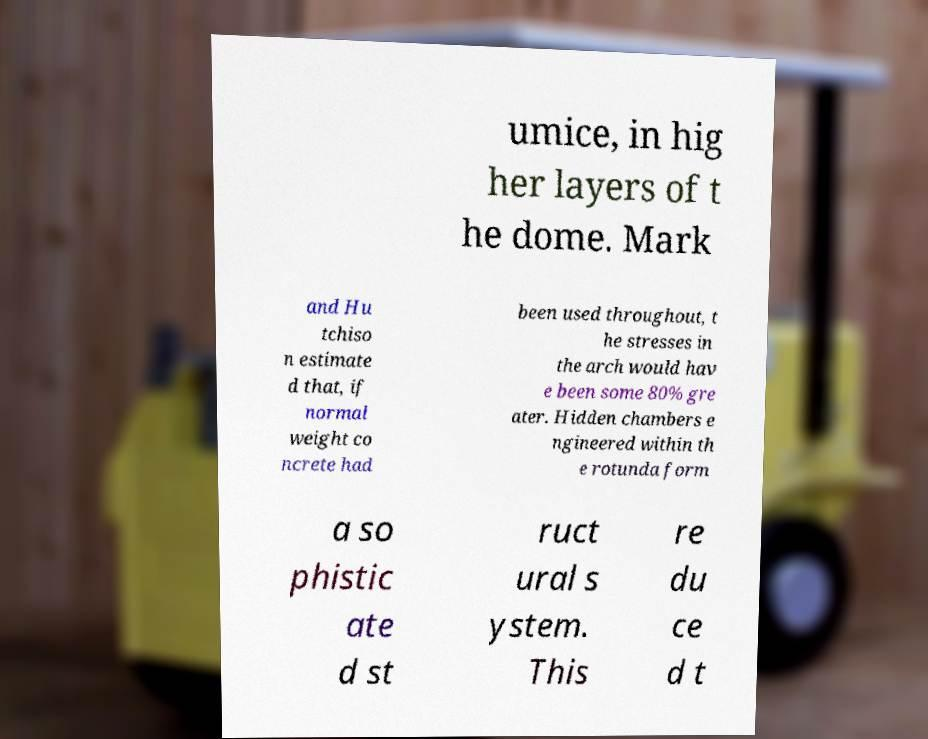For documentation purposes, I need the text within this image transcribed. Could you provide that? umice, in hig her layers of t he dome. Mark and Hu tchiso n estimate d that, if normal weight co ncrete had been used throughout, t he stresses in the arch would hav e been some 80% gre ater. Hidden chambers e ngineered within th e rotunda form a so phistic ate d st ruct ural s ystem. This re du ce d t 